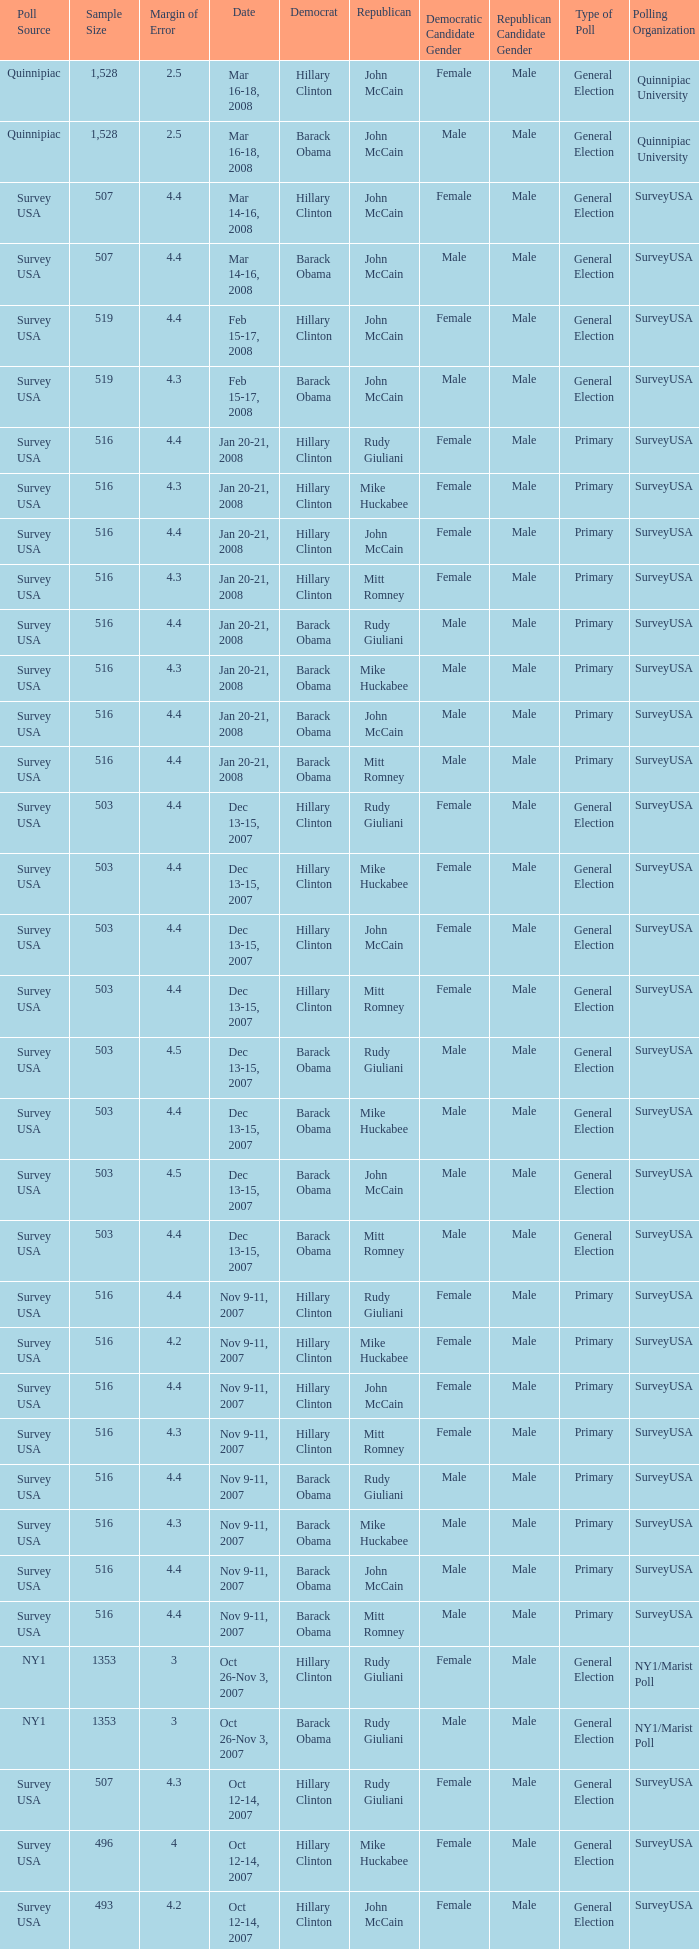What was the date of the poll with a sample size of 496 where Republican Mike Huckabee was chosen? Oct 12-14, 2007. 